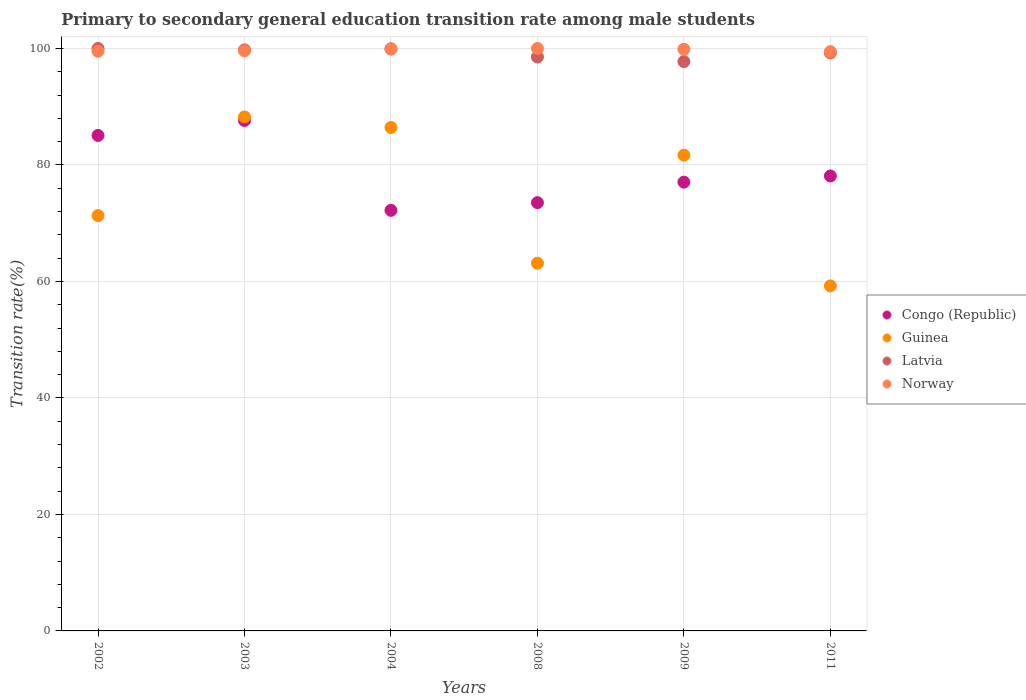Is the number of dotlines equal to the number of legend labels?
Your answer should be compact. Yes. What is the transition rate in Guinea in 2003?
Make the answer very short. 88.24. Across all years, what is the maximum transition rate in Latvia?
Offer a terse response. 99.99. Across all years, what is the minimum transition rate in Guinea?
Give a very brief answer. 59.24. In which year was the transition rate in Guinea maximum?
Your answer should be very brief. 2003. In which year was the transition rate in Norway minimum?
Your answer should be compact. 2011. What is the total transition rate in Norway in the graph?
Offer a terse response. 598.33. What is the difference between the transition rate in Norway in 2008 and that in 2011?
Make the answer very short. 0.55. What is the difference between the transition rate in Latvia in 2011 and the transition rate in Norway in 2009?
Keep it short and to the point. -0.62. What is the average transition rate in Norway per year?
Your answer should be very brief. 99.72. In the year 2011, what is the difference between the transition rate in Guinea and transition rate in Latvia?
Offer a very short reply. -40.01. What is the ratio of the transition rate in Guinea in 2008 to that in 2009?
Keep it short and to the point. 0.77. What is the difference between the highest and the second highest transition rate in Congo (Republic)?
Provide a short and direct response. 2.56. What is the difference between the highest and the lowest transition rate in Norway?
Make the answer very short. 0.55. Is the sum of the transition rate in Congo (Republic) in 2003 and 2011 greater than the maximum transition rate in Latvia across all years?
Provide a short and direct response. Yes. Is it the case that in every year, the sum of the transition rate in Guinea and transition rate in Latvia  is greater than the transition rate in Congo (Republic)?
Offer a terse response. Yes. Is the transition rate in Latvia strictly greater than the transition rate in Congo (Republic) over the years?
Offer a terse response. Yes. Is the transition rate in Guinea strictly less than the transition rate in Norway over the years?
Make the answer very short. Yes. Are the values on the major ticks of Y-axis written in scientific E-notation?
Keep it short and to the point. No. Does the graph contain any zero values?
Offer a very short reply. No. How many legend labels are there?
Make the answer very short. 4. What is the title of the graph?
Give a very brief answer. Primary to secondary general education transition rate among male students. What is the label or title of the Y-axis?
Provide a short and direct response. Transition rate(%). What is the Transition rate(%) in Congo (Republic) in 2002?
Give a very brief answer. 85.06. What is the Transition rate(%) in Guinea in 2002?
Provide a short and direct response. 71.3. What is the Transition rate(%) of Latvia in 2002?
Provide a short and direct response. 99.99. What is the Transition rate(%) of Norway in 2002?
Offer a very short reply. 99.51. What is the Transition rate(%) of Congo (Republic) in 2003?
Provide a short and direct response. 87.63. What is the Transition rate(%) in Guinea in 2003?
Provide a short and direct response. 88.24. What is the Transition rate(%) in Latvia in 2003?
Offer a very short reply. 99.76. What is the Transition rate(%) in Norway in 2003?
Provide a short and direct response. 99.6. What is the Transition rate(%) of Congo (Republic) in 2004?
Provide a succinct answer. 72.21. What is the Transition rate(%) in Guinea in 2004?
Ensure brevity in your answer.  86.43. What is the Transition rate(%) in Latvia in 2004?
Provide a succinct answer. 99.93. What is the Transition rate(%) in Norway in 2004?
Offer a very short reply. 99.9. What is the Transition rate(%) of Congo (Republic) in 2008?
Provide a short and direct response. 73.52. What is the Transition rate(%) of Guinea in 2008?
Offer a very short reply. 63.14. What is the Transition rate(%) of Latvia in 2008?
Ensure brevity in your answer.  98.53. What is the Transition rate(%) in Congo (Republic) in 2009?
Your answer should be very brief. 77.05. What is the Transition rate(%) in Guinea in 2009?
Provide a succinct answer. 81.68. What is the Transition rate(%) of Latvia in 2009?
Your answer should be very brief. 97.75. What is the Transition rate(%) of Norway in 2009?
Your answer should be very brief. 99.87. What is the Transition rate(%) of Congo (Republic) in 2011?
Your answer should be compact. 78.1. What is the Transition rate(%) in Guinea in 2011?
Offer a terse response. 59.24. What is the Transition rate(%) in Latvia in 2011?
Keep it short and to the point. 99.25. What is the Transition rate(%) of Norway in 2011?
Offer a terse response. 99.45. Across all years, what is the maximum Transition rate(%) of Congo (Republic)?
Make the answer very short. 87.63. Across all years, what is the maximum Transition rate(%) of Guinea?
Your response must be concise. 88.24. Across all years, what is the maximum Transition rate(%) in Latvia?
Provide a succinct answer. 99.99. Across all years, what is the minimum Transition rate(%) in Congo (Republic)?
Ensure brevity in your answer.  72.21. Across all years, what is the minimum Transition rate(%) of Guinea?
Make the answer very short. 59.24. Across all years, what is the minimum Transition rate(%) of Latvia?
Make the answer very short. 97.75. Across all years, what is the minimum Transition rate(%) in Norway?
Provide a short and direct response. 99.45. What is the total Transition rate(%) of Congo (Republic) in the graph?
Provide a short and direct response. 473.57. What is the total Transition rate(%) of Guinea in the graph?
Your answer should be very brief. 450.03. What is the total Transition rate(%) in Latvia in the graph?
Keep it short and to the point. 595.2. What is the total Transition rate(%) of Norway in the graph?
Provide a short and direct response. 598.33. What is the difference between the Transition rate(%) of Congo (Republic) in 2002 and that in 2003?
Provide a short and direct response. -2.56. What is the difference between the Transition rate(%) in Guinea in 2002 and that in 2003?
Give a very brief answer. -16.94. What is the difference between the Transition rate(%) of Latvia in 2002 and that in 2003?
Keep it short and to the point. 0.23. What is the difference between the Transition rate(%) of Norway in 2002 and that in 2003?
Offer a terse response. -0.09. What is the difference between the Transition rate(%) of Congo (Republic) in 2002 and that in 2004?
Give a very brief answer. 12.86. What is the difference between the Transition rate(%) of Guinea in 2002 and that in 2004?
Ensure brevity in your answer.  -15.13. What is the difference between the Transition rate(%) of Latvia in 2002 and that in 2004?
Give a very brief answer. 0.05. What is the difference between the Transition rate(%) of Norway in 2002 and that in 2004?
Give a very brief answer. -0.39. What is the difference between the Transition rate(%) in Congo (Republic) in 2002 and that in 2008?
Your response must be concise. 11.54. What is the difference between the Transition rate(%) of Guinea in 2002 and that in 2008?
Keep it short and to the point. 8.16. What is the difference between the Transition rate(%) of Latvia in 2002 and that in 2008?
Ensure brevity in your answer.  1.46. What is the difference between the Transition rate(%) in Norway in 2002 and that in 2008?
Keep it short and to the point. -0.49. What is the difference between the Transition rate(%) of Congo (Republic) in 2002 and that in 2009?
Provide a short and direct response. 8.01. What is the difference between the Transition rate(%) in Guinea in 2002 and that in 2009?
Make the answer very short. -10.38. What is the difference between the Transition rate(%) of Latvia in 2002 and that in 2009?
Make the answer very short. 2.24. What is the difference between the Transition rate(%) of Norway in 2002 and that in 2009?
Your response must be concise. -0.35. What is the difference between the Transition rate(%) of Congo (Republic) in 2002 and that in 2011?
Give a very brief answer. 6.96. What is the difference between the Transition rate(%) of Guinea in 2002 and that in 2011?
Your answer should be very brief. 12.06. What is the difference between the Transition rate(%) in Latvia in 2002 and that in 2011?
Your answer should be compact. 0.74. What is the difference between the Transition rate(%) of Norway in 2002 and that in 2011?
Your answer should be compact. 0.07. What is the difference between the Transition rate(%) in Congo (Republic) in 2003 and that in 2004?
Provide a short and direct response. 15.42. What is the difference between the Transition rate(%) in Guinea in 2003 and that in 2004?
Give a very brief answer. 1.81. What is the difference between the Transition rate(%) of Latvia in 2003 and that in 2004?
Provide a short and direct response. -0.17. What is the difference between the Transition rate(%) in Norway in 2003 and that in 2004?
Offer a terse response. -0.3. What is the difference between the Transition rate(%) of Congo (Republic) in 2003 and that in 2008?
Give a very brief answer. 14.1. What is the difference between the Transition rate(%) in Guinea in 2003 and that in 2008?
Offer a very short reply. 25.1. What is the difference between the Transition rate(%) in Latvia in 2003 and that in 2008?
Give a very brief answer. 1.23. What is the difference between the Transition rate(%) of Norway in 2003 and that in 2008?
Ensure brevity in your answer.  -0.4. What is the difference between the Transition rate(%) of Congo (Republic) in 2003 and that in 2009?
Your answer should be very brief. 10.58. What is the difference between the Transition rate(%) of Guinea in 2003 and that in 2009?
Offer a very short reply. 6.56. What is the difference between the Transition rate(%) in Latvia in 2003 and that in 2009?
Provide a succinct answer. 2.01. What is the difference between the Transition rate(%) in Norway in 2003 and that in 2009?
Make the answer very short. -0.27. What is the difference between the Transition rate(%) in Congo (Republic) in 2003 and that in 2011?
Give a very brief answer. 9.52. What is the difference between the Transition rate(%) in Guinea in 2003 and that in 2011?
Give a very brief answer. 29. What is the difference between the Transition rate(%) in Latvia in 2003 and that in 2011?
Ensure brevity in your answer.  0.51. What is the difference between the Transition rate(%) of Norway in 2003 and that in 2011?
Provide a succinct answer. 0.15. What is the difference between the Transition rate(%) of Congo (Republic) in 2004 and that in 2008?
Keep it short and to the point. -1.32. What is the difference between the Transition rate(%) in Guinea in 2004 and that in 2008?
Ensure brevity in your answer.  23.29. What is the difference between the Transition rate(%) of Latvia in 2004 and that in 2008?
Your answer should be very brief. 1.4. What is the difference between the Transition rate(%) of Norway in 2004 and that in 2008?
Give a very brief answer. -0.1. What is the difference between the Transition rate(%) in Congo (Republic) in 2004 and that in 2009?
Your answer should be very brief. -4.84. What is the difference between the Transition rate(%) of Guinea in 2004 and that in 2009?
Give a very brief answer. 4.75. What is the difference between the Transition rate(%) of Latvia in 2004 and that in 2009?
Ensure brevity in your answer.  2.18. What is the difference between the Transition rate(%) in Norway in 2004 and that in 2009?
Ensure brevity in your answer.  0.04. What is the difference between the Transition rate(%) of Congo (Republic) in 2004 and that in 2011?
Keep it short and to the point. -5.9. What is the difference between the Transition rate(%) of Guinea in 2004 and that in 2011?
Provide a succinct answer. 27.19. What is the difference between the Transition rate(%) in Latvia in 2004 and that in 2011?
Offer a terse response. 0.69. What is the difference between the Transition rate(%) in Norway in 2004 and that in 2011?
Your answer should be compact. 0.46. What is the difference between the Transition rate(%) in Congo (Republic) in 2008 and that in 2009?
Make the answer very short. -3.53. What is the difference between the Transition rate(%) of Guinea in 2008 and that in 2009?
Give a very brief answer. -18.54. What is the difference between the Transition rate(%) of Latvia in 2008 and that in 2009?
Your response must be concise. 0.78. What is the difference between the Transition rate(%) in Norway in 2008 and that in 2009?
Keep it short and to the point. 0.13. What is the difference between the Transition rate(%) in Congo (Republic) in 2008 and that in 2011?
Make the answer very short. -4.58. What is the difference between the Transition rate(%) in Guinea in 2008 and that in 2011?
Ensure brevity in your answer.  3.91. What is the difference between the Transition rate(%) in Latvia in 2008 and that in 2011?
Your answer should be very brief. -0.72. What is the difference between the Transition rate(%) in Norway in 2008 and that in 2011?
Provide a short and direct response. 0.55. What is the difference between the Transition rate(%) of Congo (Republic) in 2009 and that in 2011?
Offer a terse response. -1.05. What is the difference between the Transition rate(%) in Guinea in 2009 and that in 2011?
Keep it short and to the point. 22.45. What is the difference between the Transition rate(%) of Latvia in 2009 and that in 2011?
Offer a very short reply. -1.5. What is the difference between the Transition rate(%) in Norway in 2009 and that in 2011?
Your response must be concise. 0.42. What is the difference between the Transition rate(%) in Congo (Republic) in 2002 and the Transition rate(%) in Guinea in 2003?
Ensure brevity in your answer.  -3.18. What is the difference between the Transition rate(%) of Congo (Republic) in 2002 and the Transition rate(%) of Latvia in 2003?
Offer a terse response. -14.7. What is the difference between the Transition rate(%) of Congo (Republic) in 2002 and the Transition rate(%) of Norway in 2003?
Offer a terse response. -14.54. What is the difference between the Transition rate(%) in Guinea in 2002 and the Transition rate(%) in Latvia in 2003?
Provide a short and direct response. -28.46. What is the difference between the Transition rate(%) in Guinea in 2002 and the Transition rate(%) in Norway in 2003?
Ensure brevity in your answer.  -28.3. What is the difference between the Transition rate(%) of Latvia in 2002 and the Transition rate(%) of Norway in 2003?
Offer a terse response. 0.39. What is the difference between the Transition rate(%) in Congo (Republic) in 2002 and the Transition rate(%) in Guinea in 2004?
Offer a terse response. -1.37. What is the difference between the Transition rate(%) of Congo (Republic) in 2002 and the Transition rate(%) of Latvia in 2004?
Offer a very short reply. -14.87. What is the difference between the Transition rate(%) of Congo (Republic) in 2002 and the Transition rate(%) of Norway in 2004?
Provide a short and direct response. -14.84. What is the difference between the Transition rate(%) in Guinea in 2002 and the Transition rate(%) in Latvia in 2004?
Provide a short and direct response. -28.63. What is the difference between the Transition rate(%) in Guinea in 2002 and the Transition rate(%) in Norway in 2004?
Keep it short and to the point. -28.6. What is the difference between the Transition rate(%) in Latvia in 2002 and the Transition rate(%) in Norway in 2004?
Give a very brief answer. 0.08. What is the difference between the Transition rate(%) in Congo (Republic) in 2002 and the Transition rate(%) in Guinea in 2008?
Your response must be concise. 21.92. What is the difference between the Transition rate(%) in Congo (Republic) in 2002 and the Transition rate(%) in Latvia in 2008?
Ensure brevity in your answer.  -13.47. What is the difference between the Transition rate(%) in Congo (Republic) in 2002 and the Transition rate(%) in Norway in 2008?
Your answer should be compact. -14.94. What is the difference between the Transition rate(%) of Guinea in 2002 and the Transition rate(%) of Latvia in 2008?
Your answer should be compact. -27.23. What is the difference between the Transition rate(%) in Guinea in 2002 and the Transition rate(%) in Norway in 2008?
Provide a short and direct response. -28.7. What is the difference between the Transition rate(%) of Latvia in 2002 and the Transition rate(%) of Norway in 2008?
Offer a terse response. -0.01. What is the difference between the Transition rate(%) of Congo (Republic) in 2002 and the Transition rate(%) of Guinea in 2009?
Keep it short and to the point. 3.38. What is the difference between the Transition rate(%) of Congo (Republic) in 2002 and the Transition rate(%) of Latvia in 2009?
Your answer should be compact. -12.69. What is the difference between the Transition rate(%) in Congo (Republic) in 2002 and the Transition rate(%) in Norway in 2009?
Provide a succinct answer. -14.8. What is the difference between the Transition rate(%) of Guinea in 2002 and the Transition rate(%) of Latvia in 2009?
Your response must be concise. -26.45. What is the difference between the Transition rate(%) of Guinea in 2002 and the Transition rate(%) of Norway in 2009?
Offer a very short reply. -28.57. What is the difference between the Transition rate(%) in Latvia in 2002 and the Transition rate(%) in Norway in 2009?
Offer a terse response. 0.12. What is the difference between the Transition rate(%) of Congo (Republic) in 2002 and the Transition rate(%) of Guinea in 2011?
Ensure brevity in your answer.  25.83. What is the difference between the Transition rate(%) of Congo (Republic) in 2002 and the Transition rate(%) of Latvia in 2011?
Provide a short and direct response. -14.18. What is the difference between the Transition rate(%) in Congo (Republic) in 2002 and the Transition rate(%) in Norway in 2011?
Make the answer very short. -14.39. What is the difference between the Transition rate(%) of Guinea in 2002 and the Transition rate(%) of Latvia in 2011?
Your response must be concise. -27.94. What is the difference between the Transition rate(%) in Guinea in 2002 and the Transition rate(%) in Norway in 2011?
Your answer should be compact. -28.15. What is the difference between the Transition rate(%) in Latvia in 2002 and the Transition rate(%) in Norway in 2011?
Your answer should be compact. 0.54. What is the difference between the Transition rate(%) in Congo (Republic) in 2003 and the Transition rate(%) in Guinea in 2004?
Give a very brief answer. 1.2. What is the difference between the Transition rate(%) in Congo (Republic) in 2003 and the Transition rate(%) in Latvia in 2004?
Ensure brevity in your answer.  -12.31. What is the difference between the Transition rate(%) in Congo (Republic) in 2003 and the Transition rate(%) in Norway in 2004?
Give a very brief answer. -12.28. What is the difference between the Transition rate(%) of Guinea in 2003 and the Transition rate(%) of Latvia in 2004?
Give a very brief answer. -11.69. What is the difference between the Transition rate(%) of Guinea in 2003 and the Transition rate(%) of Norway in 2004?
Your answer should be compact. -11.66. What is the difference between the Transition rate(%) of Latvia in 2003 and the Transition rate(%) of Norway in 2004?
Your answer should be very brief. -0.14. What is the difference between the Transition rate(%) of Congo (Republic) in 2003 and the Transition rate(%) of Guinea in 2008?
Give a very brief answer. 24.48. What is the difference between the Transition rate(%) in Congo (Republic) in 2003 and the Transition rate(%) in Latvia in 2008?
Keep it short and to the point. -10.91. What is the difference between the Transition rate(%) of Congo (Republic) in 2003 and the Transition rate(%) of Norway in 2008?
Ensure brevity in your answer.  -12.37. What is the difference between the Transition rate(%) of Guinea in 2003 and the Transition rate(%) of Latvia in 2008?
Make the answer very short. -10.29. What is the difference between the Transition rate(%) in Guinea in 2003 and the Transition rate(%) in Norway in 2008?
Provide a short and direct response. -11.76. What is the difference between the Transition rate(%) of Latvia in 2003 and the Transition rate(%) of Norway in 2008?
Offer a terse response. -0.24. What is the difference between the Transition rate(%) of Congo (Republic) in 2003 and the Transition rate(%) of Guinea in 2009?
Ensure brevity in your answer.  5.94. What is the difference between the Transition rate(%) of Congo (Republic) in 2003 and the Transition rate(%) of Latvia in 2009?
Offer a very short reply. -10.12. What is the difference between the Transition rate(%) of Congo (Republic) in 2003 and the Transition rate(%) of Norway in 2009?
Your response must be concise. -12.24. What is the difference between the Transition rate(%) in Guinea in 2003 and the Transition rate(%) in Latvia in 2009?
Your answer should be very brief. -9.51. What is the difference between the Transition rate(%) in Guinea in 2003 and the Transition rate(%) in Norway in 2009?
Provide a succinct answer. -11.63. What is the difference between the Transition rate(%) of Latvia in 2003 and the Transition rate(%) of Norway in 2009?
Your response must be concise. -0.11. What is the difference between the Transition rate(%) of Congo (Republic) in 2003 and the Transition rate(%) of Guinea in 2011?
Offer a very short reply. 28.39. What is the difference between the Transition rate(%) of Congo (Republic) in 2003 and the Transition rate(%) of Latvia in 2011?
Your answer should be very brief. -11.62. What is the difference between the Transition rate(%) in Congo (Republic) in 2003 and the Transition rate(%) in Norway in 2011?
Make the answer very short. -11.82. What is the difference between the Transition rate(%) in Guinea in 2003 and the Transition rate(%) in Latvia in 2011?
Your answer should be very brief. -11.01. What is the difference between the Transition rate(%) in Guinea in 2003 and the Transition rate(%) in Norway in 2011?
Keep it short and to the point. -11.21. What is the difference between the Transition rate(%) of Latvia in 2003 and the Transition rate(%) of Norway in 2011?
Provide a succinct answer. 0.31. What is the difference between the Transition rate(%) of Congo (Republic) in 2004 and the Transition rate(%) of Guinea in 2008?
Keep it short and to the point. 9.06. What is the difference between the Transition rate(%) of Congo (Republic) in 2004 and the Transition rate(%) of Latvia in 2008?
Provide a short and direct response. -26.32. What is the difference between the Transition rate(%) of Congo (Republic) in 2004 and the Transition rate(%) of Norway in 2008?
Offer a very short reply. -27.79. What is the difference between the Transition rate(%) of Guinea in 2004 and the Transition rate(%) of Latvia in 2008?
Your response must be concise. -12.1. What is the difference between the Transition rate(%) in Guinea in 2004 and the Transition rate(%) in Norway in 2008?
Your answer should be very brief. -13.57. What is the difference between the Transition rate(%) in Latvia in 2004 and the Transition rate(%) in Norway in 2008?
Keep it short and to the point. -0.07. What is the difference between the Transition rate(%) in Congo (Republic) in 2004 and the Transition rate(%) in Guinea in 2009?
Make the answer very short. -9.48. What is the difference between the Transition rate(%) in Congo (Republic) in 2004 and the Transition rate(%) in Latvia in 2009?
Offer a terse response. -25.54. What is the difference between the Transition rate(%) in Congo (Republic) in 2004 and the Transition rate(%) in Norway in 2009?
Provide a succinct answer. -27.66. What is the difference between the Transition rate(%) in Guinea in 2004 and the Transition rate(%) in Latvia in 2009?
Offer a very short reply. -11.32. What is the difference between the Transition rate(%) in Guinea in 2004 and the Transition rate(%) in Norway in 2009?
Your response must be concise. -13.44. What is the difference between the Transition rate(%) in Latvia in 2004 and the Transition rate(%) in Norway in 2009?
Ensure brevity in your answer.  0.07. What is the difference between the Transition rate(%) in Congo (Republic) in 2004 and the Transition rate(%) in Guinea in 2011?
Your response must be concise. 12.97. What is the difference between the Transition rate(%) of Congo (Republic) in 2004 and the Transition rate(%) of Latvia in 2011?
Ensure brevity in your answer.  -27.04. What is the difference between the Transition rate(%) in Congo (Republic) in 2004 and the Transition rate(%) in Norway in 2011?
Make the answer very short. -27.24. What is the difference between the Transition rate(%) of Guinea in 2004 and the Transition rate(%) of Latvia in 2011?
Your response must be concise. -12.82. What is the difference between the Transition rate(%) in Guinea in 2004 and the Transition rate(%) in Norway in 2011?
Make the answer very short. -13.02. What is the difference between the Transition rate(%) of Latvia in 2004 and the Transition rate(%) of Norway in 2011?
Make the answer very short. 0.49. What is the difference between the Transition rate(%) of Congo (Republic) in 2008 and the Transition rate(%) of Guinea in 2009?
Your answer should be compact. -8.16. What is the difference between the Transition rate(%) of Congo (Republic) in 2008 and the Transition rate(%) of Latvia in 2009?
Provide a short and direct response. -24.22. What is the difference between the Transition rate(%) of Congo (Republic) in 2008 and the Transition rate(%) of Norway in 2009?
Your answer should be compact. -26.34. What is the difference between the Transition rate(%) of Guinea in 2008 and the Transition rate(%) of Latvia in 2009?
Provide a succinct answer. -34.61. What is the difference between the Transition rate(%) of Guinea in 2008 and the Transition rate(%) of Norway in 2009?
Make the answer very short. -36.72. What is the difference between the Transition rate(%) in Latvia in 2008 and the Transition rate(%) in Norway in 2009?
Make the answer very short. -1.34. What is the difference between the Transition rate(%) of Congo (Republic) in 2008 and the Transition rate(%) of Guinea in 2011?
Your answer should be very brief. 14.29. What is the difference between the Transition rate(%) in Congo (Republic) in 2008 and the Transition rate(%) in Latvia in 2011?
Offer a terse response. -25.72. What is the difference between the Transition rate(%) of Congo (Republic) in 2008 and the Transition rate(%) of Norway in 2011?
Ensure brevity in your answer.  -25.92. What is the difference between the Transition rate(%) in Guinea in 2008 and the Transition rate(%) in Latvia in 2011?
Offer a very short reply. -36.1. What is the difference between the Transition rate(%) of Guinea in 2008 and the Transition rate(%) of Norway in 2011?
Offer a very short reply. -36.3. What is the difference between the Transition rate(%) of Latvia in 2008 and the Transition rate(%) of Norway in 2011?
Ensure brevity in your answer.  -0.92. What is the difference between the Transition rate(%) of Congo (Republic) in 2009 and the Transition rate(%) of Guinea in 2011?
Give a very brief answer. 17.81. What is the difference between the Transition rate(%) of Congo (Republic) in 2009 and the Transition rate(%) of Latvia in 2011?
Provide a succinct answer. -22.2. What is the difference between the Transition rate(%) in Congo (Republic) in 2009 and the Transition rate(%) in Norway in 2011?
Your answer should be compact. -22.4. What is the difference between the Transition rate(%) in Guinea in 2009 and the Transition rate(%) in Latvia in 2011?
Your response must be concise. -17.56. What is the difference between the Transition rate(%) of Guinea in 2009 and the Transition rate(%) of Norway in 2011?
Ensure brevity in your answer.  -17.76. What is the difference between the Transition rate(%) in Latvia in 2009 and the Transition rate(%) in Norway in 2011?
Give a very brief answer. -1.7. What is the average Transition rate(%) in Congo (Republic) per year?
Provide a succinct answer. 78.93. What is the average Transition rate(%) in Guinea per year?
Your answer should be compact. 75.01. What is the average Transition rate(%) in Latvia per year?
Offer a very short reply. 99.2. What is the average Transition rate(%) in Norway per year?
Your response must be concise. 99.72. In the year 2002, what is the difference between the Transition rate(%) of Congo (Republic) and Transition rate(%) of Guinea?
Provide a succinct answer. 13.76. In the year 2002, what is the difference between the Transition rate(%) in Congo (Republic) and Transition rate(%) in Latvia?
Your answer should be compact. -14.93. In the year 2002, what is the difference between the Transition rate(%) in Congo (Republic) and Transition rate(%) in Norway?
Offer a very short reply. -14.45. In the year 2002, what is the difference between the Transition rate(%) of Guinea and Transition rate(%) of Latvia?
Provide a succinct answer. -28.69. In the year 2002, what is the difference between the Transition rate(%) in Guinea and Transition rate(%) in Norway?
Make the answer very short. -28.21. In the year 2002, what is the difference between the Transition rate(%) in Latvia and Transition rate(%) in Norway?
Give a very brief answer. 0.47. In the year 2003, what is the difference between the Transition rate(%) of Congo (Republic) and Transition rate(%) of Guinea?
Give a very brief answer. -0.61. In the year 2003, what is the difference between the Transition rate(%) in Congo (Republic) and Transition rate(%) in Latvia?
Offer a terse response. -12.13. In the year 2003, what is the difference between the Transition rate(%) in Congo (Republic) and Transition rate(%) in Norway?
Keep it short and to the point. -11.98. In the year 2003, what is the difference between the Transition rate(%) in Guinea and Transition rate(%) in Latvia?
Offer a very short reply. -11.52. In the year 2003, what is the difference between the Transition rate(%) of Guinea and Transition rate(%) of Norway?
Give a very brief answer. -11.36. In the year 2003, what is the difference between the Transition rate(%) in Latvia and Transition rate(%) in Norway?
Provide a succinct answer. 0.16. In the year 2004, what is the difference between the Transition rate(%) in Congo (Republic) and Transition rate(%) in Guinea?
Ensure brevity in your answer.  -14.22. In the year 2004, what is the difference between the Transition rate(%) of Congo (Republic) and Transition rate(%) of Latvia?
Your answer should be compact. -27.73. In the year 2004, what is the difference between the Transition rate(%) in Congo (Republic) and Transition rate(%) in Norway?
Offer a very short reply. -27.7. In the year 2004, what is the difference between the Transition rate(%) in Guinea and Transition rate(%) in Latvia?
Ensure brevity in your answer.  -13.5. In the year 2004, what is the difference between the Transition rate(%) of Guinea and Transition rate(%) of Norway?
Your answer should be compact. -13.47. In the year 2004, what is the difference between the Transition rate(%) of Latvia and Transition rate(%) of Norway?
Make the answer very short. 0.03. In the year 2008, what is the difference between the Transition rate(%) of Congo (Republic) and Transition rate(%) of Guinea?
Provide a short and direct response. 10.38. In the year 2008, what is the difference between the Transition rate(%) of Congo (Republic) and Transition rate(%) of Latvia?
Make the answer very short. -25.01. In the year 2008, what is the difference between the Transition rate(%) in Congo (Republic) and Transition rate(%) in Norway?
Offer a very short reply. -26.48. In the year 2008, what is the difference between the Transition rate(%) in Guinea and Transition rate(%) in Latvia?
Your answer should be compact. -35.39. In the year 2008, what is the difference between the Transition rate(%) in Guinea and Transition rate(%) in Norway?
Your response must be concise. -36.86. In the year 2008, what is the difference between the Transition rate(%) of Latvia and Transition rate(%) of Norway?
Ensure brevity in your answer.  -1.47. In the year 2009, what is the difference between the Transition rate(%) of Congo (Republic) and Transition rate(%) of Guinea?
Provide a succinct answer. -4.63. In the year 2009, what is the difference between the Transition rate(%) in Congo (Republic) and Transition rate(%) in Latvia?
Provide a succinct answer. -20.7. In the year 2009, what is the difference between the Transition rate(%) of Congo (Republic) and Transition rate(%) of Norway?
Make the answer very short. -22.82. In the year 2009, what is the difference between the Transition rate(%) in Guinea and Transition rate(%) in Latvia?
Your answer should be very brief. -16.06. In the year 2009, what is the difference between the Transition rate(%) in Guinea and Transition rate(%) in Norway?
Keep it short and to the point. -18.18. In the year 2009, what is the difference between the Transition rate(%) in Latvia and Transition rate(%) in Norway?
Keep it short and to the point. -2.12. In the year 2011, what is the difference between the Transition rate(%) in Congo (Republic) and Transition rate(%) in Guinea?
Your response must be concise. 18.87. In the year 2011, what is the difference between the Transition rate(%) of Congo (Republic) and Transition rate(%) of Latvia?
Your response must be concise. -21.14. In the year 2011, what is the difference between the Transition rate(%) in Congo (Republic) and Transition rate(%) in Norway?
Your response must be concise. -21.34. In the year 2011, what is the difference between the Transition rate(%) of Guinea and Transition rate(%) of Latvia?
Provide a succinct answer. -40.01. In the year 2011, what is the difference between the Transition rate(%) in Guinea and Transition rate(%) in Norway?
Provide a short and direct response. -40.21. In the year 2011, what is the difference between the Transition rate(%) of Latvia and Transition rate(%) of Norway?
Provide a succinct answer. -0.2. What is the ratio of the Transition rate(%) in Congo (Republic) in 2002 to that in 2003?
Keep it short and to the point. 0.97. What is the ratio of the Transition rate(%) in Guinea in 2002 to that in 2003?
Your answer should be very brief. 0.81. What is the ratio of the Transition rate(%) of Latvia in 2002 to that in 2003?
Ensure brevity in your answer.  1. What is the ratio of the Transition rate(%) in Norway in 2002 to that in 2003?
Ensure brevity in your answer.  1. What is the ratio of the Transition rate(%) of Congo (Republic) in 2002 to that in 2004?
Give a very brief answer. 1.18. What is the ratio of the Transition rate(%) in Guinea in 2002 to that in 2004?
Give a very brief answer. 0.82. What is the ratio of the Transition rate(%) of Congo (Republic) in 2002 to that in 2008?
Your answer should be very brief. 1.16. What is the ratio of the Transition rate(%) of Guinea in 2002 to that in 2008?
Your answer should be compact. 1.13. What is the ratio of the Transition rate(%) in Latvia in 2002 to that in 2008?
Your answer should be compact. 1.01. What is the ratio of the Transition rate(%) of Norway in 2002 to that in 2008?
Make the answer very short. 1. What is the ratio of the Transition rate(%) in Congo (Republic) in 2002 to that in 2009?
Offer a terse response. 1.1. What is the ratio of the Transition rate(%) in Guinea in 2002 to that in 2009?
Offer a very short reply. 0.87. What is the ratio of the Transition rate(%) of Latvia in 2002 to that in 2009?
Ensure brevity in your answer.  1.02. What is the ratio of the Transition rate(%) in Norway in 2002 to that in 2009?
Your answer should be compact. 1. What is the ratio of the Transition rate(%) of Congo (Republic) in 2002 to that in 2011?
Provide a succinct answer. 1.09. What is the ratio of the Transition rate(%) of Guinea in 2002 to that in 2011?
Your answer should be very brief. 1.2. What is the ratio of the Transition rate(%) of Latvia in 2002 to that in 2011?
Your response must be concise. 1.01. What is the ratio of the Transition rate(%) of Norway in 2002 to that in 2011?
Provide a short and direct response. 1. What is the ratio of the Transition rate(%) in Congo (Republic) in 2003 to that in 2004?
Your response must be concise. 1.21. What is the ratio of the Transition rate(%) of Congo (Republic) in 2003 to that in 2008?
Offer a very short reply. 1.19. What is the ratio of the Transition rate(%) of Guinea in 2003 to that in 2008?
Make the answer very short. 1.4. What is the ratio of the Transition rate(%) of Latvia in 2003 to that in 2008?
Provide a succinct answer. 1.01. What is the ratio of the Transition rate(%) in Norway in 2003 to that in 2008?
Your response must be concise. 1. What is the ratio of the Transition rate(%) of Congo (Republic) in 2003 to that in 2009?
Your answer should be very brief. 1.14. What is the ratio of the Transition rate(%) of Guinea in 2003 to that in 2009?
Provide a short and direct response. 1.08. What is the ratio of the Transition rate(%) in Latvia in 2003 to that in 2009?
Your response must be concise. 1.02. What is the ratio of the Transition rate(%) of Congo (Republic) in 2003 to that in 2011?
Your answer should be very brief. 1.12. What is the ratio of the Transition rate(%) in Guinea in 2003 to that in 2011?
Provide a short and direct response. 1.49. What is the ratio of the Transition rate(%) of Norway in 2003 to that in 2011?
Provide a short and direct response. 1. What is the ratio of the Transition rate(%) in Congo (Republic) in 2004 to that in 2008?
Provide a short and direct response. 0.98. What is the ratio of the Transition rate(%) in Guinea in 2004 to that in 2008?
Provide a short and direct response. 1.37. What is the ratio of the Transition rate(%) of Latvia in 2004 to that in 2008?
Provide a short and direct response. 1.01. What is the ratio of the Transition rate(%) in Congo (Republic) in 2004 to that in 2009?
Your answer should be compact. 0.94. What is the ratio of the Transition rate(%) of Guinea in 2004 to that in 2009?
Provide a short and direct response. 1.06. What is the ratio of the Transition rate(%) in Latvia in 2004 to that in 2009?
Your answer should be very brief. 1.02. What is the ratio of the Transition rate(%) in Norway in 2004 to that in 2009?
Provide a short and direct response. 1. What is the ratio of the Transition rate(%) of Congo (Republic) in 2004 to that in 2011?
Your answer should be very brief. 0.92. What is the ratio of the Transition rate(%) in Guinea in 2004 to that in 2011?
Give a very brief answer. 1.46. What is the ratio of the Transition rate(%) of Latvia in 2004 to that in 2011?
Provide a short and direct response. 1.01. What is the ratio of the Transition rate(%) in Congo (Republic) in 2008 to that in 2009?
Provide a short and direct response. 0.95. What is the ratio of the Transition rate(%) in Guinea in 2008 to that in 2009?
Make the answer very short. 0.77. What is the ratio of the Transition rate(%) in Latvia in 2008 to that in 2009?
Make the answer very short. 1.01. What is the ratio of the Transition rate(%) in Norway in 2008 to that in 2009?
Provide a succinct answer. 1. What is the ratio of the Transition rate(%) of Congo (Republic) in 2008 to that in 2011?
Offer a very short reply. 0.94. What is the ratio of the Transition rate(%) in Guinea in 2008 to that in 2011?
Your answer should be very brief. 1.07. What is the ratio of the Transition rate(%) of Norway in 2008 to that in 2011?
Provide a succinct answer. 1.01. What is the ratio of the Transition rate(%) of Congo (Republic) in 2009 to that in 2011?
Provide a short and direct response. 0.99. What is the ratio of the Transition rate(%) in Guinea in 2009 to that in 2011?
Offer a terse response. 1.38. What is the ratio of the Transition rate(%) in Latvia in 2009 to that in 2011?
Your answer should be very brief. 0.98. What is the difference between the highest and the second highest Transition rate(%) in Congo (Republic)?
Provide a succinct answer. 2.56. What is the difference between the highest and the second highest Transition rate(%) in Guinea?
Offer a very short reply. 1.81. What is the difference between the highest and the second highest Transition rate(%) of Latvia?
Your answer should be compact. 0.05. What is the difference between the highest and the second highest Transition rate(%) in Norway?
Your response must be concise. 0.1. What is the difference between the highest and the lowest Transition rate(%) in Congo (Republic)?
Keep it short and to the point. 15.42. What is the difference between the highest and the lowest Transition rate(%) of Guinea?
Provide a succinct answer. 29. What is the difference between the highest and the lowest Transition rate(%) in Latvia?
Your answer should be very brief. 2.24. What is the difference between the highest and the lowest Transition rate(%) of Norway?
Make the answer very short. 0.55. 